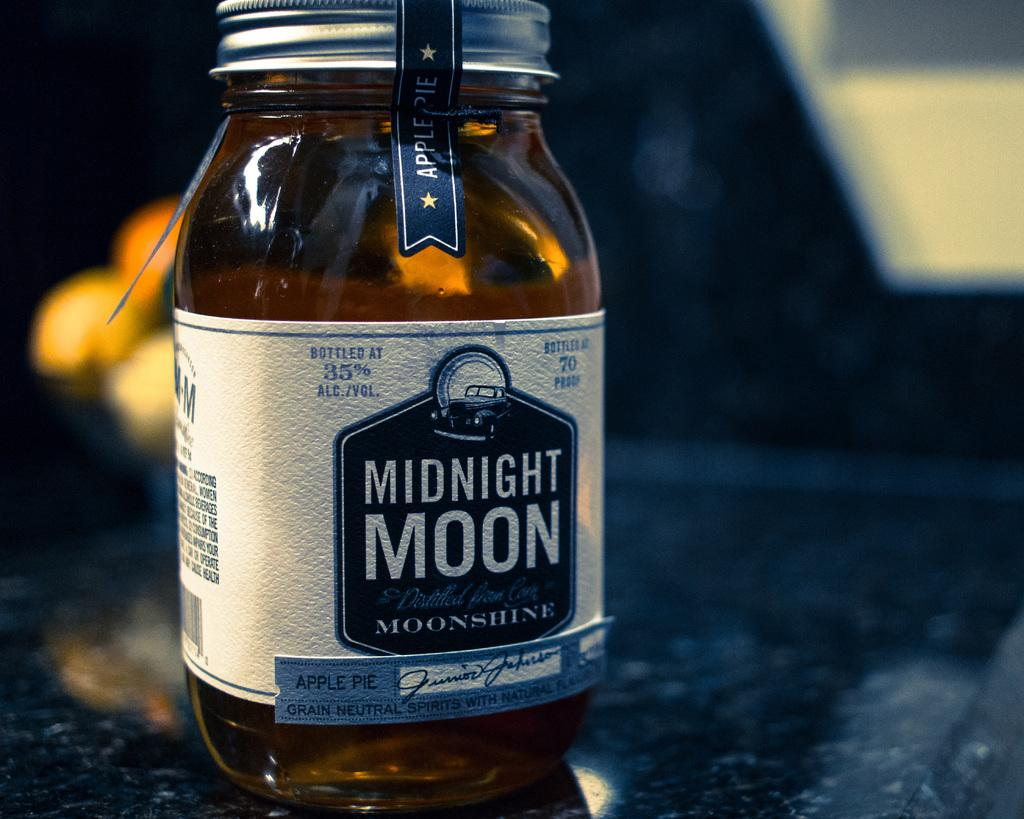<image>
Offer a succinct explanation of the picture presented. A jar has a label with blue and white text that reads, "Midnight Moon." 